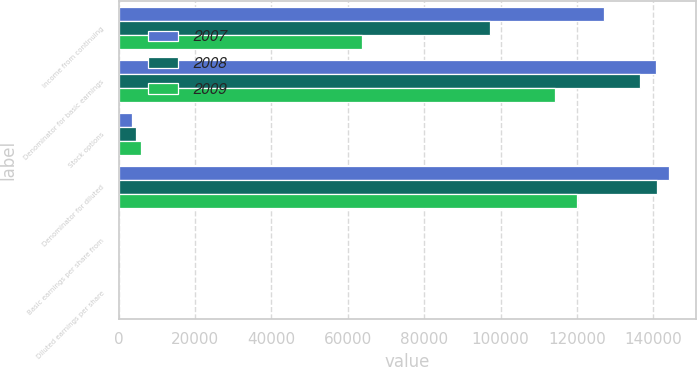Convert chart. <chart><loc_0><loc_0><loc_500><loc_500><stacked_bar_chart><ecel><fcel>Income from continuing<fcel>Denominator for basic earnings<fcel>Stock options<fcel>Denominator for diluted<fcel>Basic earnings per share from<fcel>Diluted earnings per share<nl><fcel>2007<fcel>127137<fcel>140541<fcel>3438<fcel>143990<fcel>0.9<fcel>0.88<nl><fcel>2008<fcel>97092<fcel>136488<fcel>4426<fcel>141023<fcel>0.71<fcel>0.69<nl><fcel>2009<fcel>63622<fcel>114161<fcel>5776<fcel>119937<fcel>0.56<fcel>0.53<nl></chart> 